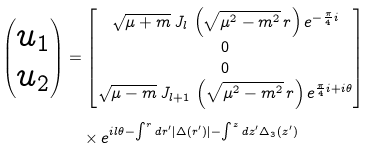Convert formula to latex. <formula><loc_0><loc_0><loc_500><loc_500>\begin{pmatrix} u _ { 1 } \\ u _ { 2 } \end{pmatrix} & = \begin{bmatrix} \sqrt { \mu + m } \, J _ { l } \, \left ( \sqrt { \mu ^ { 2 } - m ^ { 2 } } \, r \right ) e ^ { - \frac { \pi } { 4 } i } \\ 0 \\ 0 \\ \sqrt { \mu - m } \, J _ { l + 1 } \, \left ( \sqrt { \mu ^ { 2 } - m ^ { 2 } } \, r \right ) e ^ { \frac { \pi } { 4 } i + i \theta } \end{bmatrix} \\ & \quad \times e ^ { i l \theta - \int ^ { r } d r ^ { \prime } | \Delta ( r ^ { \prime } ) | - \int ^ { z } d z ^ { \prime } \Delta _ { 3 } ( z ^ { \prime } ) }</formula> 